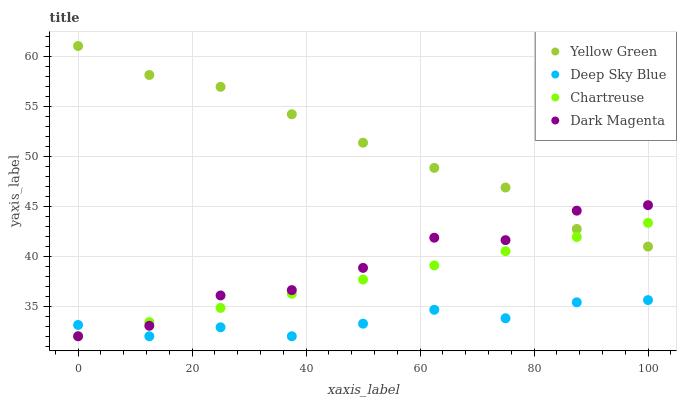Does Deep Sky Blue have the minimum area under the curve?
Answer yes or no. Yes. Does Yellow Green have the maximum area under the curve?
Answer yes or no. Yes. Does Yellow Green have the minimum area under the curve?
Answer yes or no. No. Does Deep Sky Blue have the maximum area under the curve?
Answer yes or no. No. Is Chartreuse the smoothest?
Answer yes or no. Yes. Is Dark Magenta the roughest?
Answer yes or no. Yes. Is Yellow Green the smoothest?
Answer yes or no. No. Is Yellow Green the roughest?
Answer yes or no. No. Does Chartreuse have the lowest value?
Answer yes or no. Yes. Does Yellow Green have the lowest value?
Answer yes or no. No. Does Yellow Green have the highest value?
Answer yes or no. Yes. Does Deep Sky Blue have the highest value?
Answer yes or no. No. Is Deep Sky Blue less than Yellow Green?
Answer yes or no. Yes. Is Yellow Green greater than Deep Sky Blue?
Answer yes or no. Yes. Does Chartreuse intersect Deep Sky Blue?
Answer yes or no. Yes. Is Chartreuse less than Deep Sky Blue?
Answer yes or no. No. Is Chartreuse greater than Deep Sky Blue?
Answer yes or no. No. Does Deep Sky Blue intersect Yellow Green?
Answer yes or no. No. 